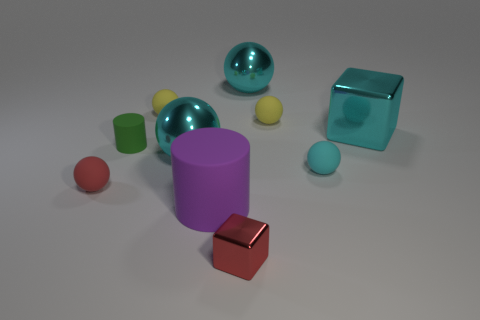What number of rubber objects have the same size as the red metallic object?
Offer a very short reply. 5. What color is the big cylinder?
Ensure brevity in your answer.  Purple. Is the color of the tiny rubber cylinder the same as the shiny thing in front of the red sphere?
Your response must be concise. No. There is a red thing that is made of the same material as the large cube; what size is it?
Provide a succinct answer. Small. Is there another cylinder that has the same color as the large matte cylinder?
Offer a terse response. No. What number of things are tiny balls that are behind the small green rubber thing or purple balls?
Your answer should be very brief. 2. Does the cyan cube have the same material as the cyan ball that is behind the large cyan block?
Your answer should be very brief. Yes. What is the size of the rubber ball that is the same color as the small cube?
Keep it short and to the point. Small. Is there a tiny red object that has the same material as the purple object?
Provide a short and direct response. Yes. What number of things are either cylinders that are to the left of the large matte cylinder or large shiny things behind the small green rubber cylinder?
Offer a very short reply. 3. 